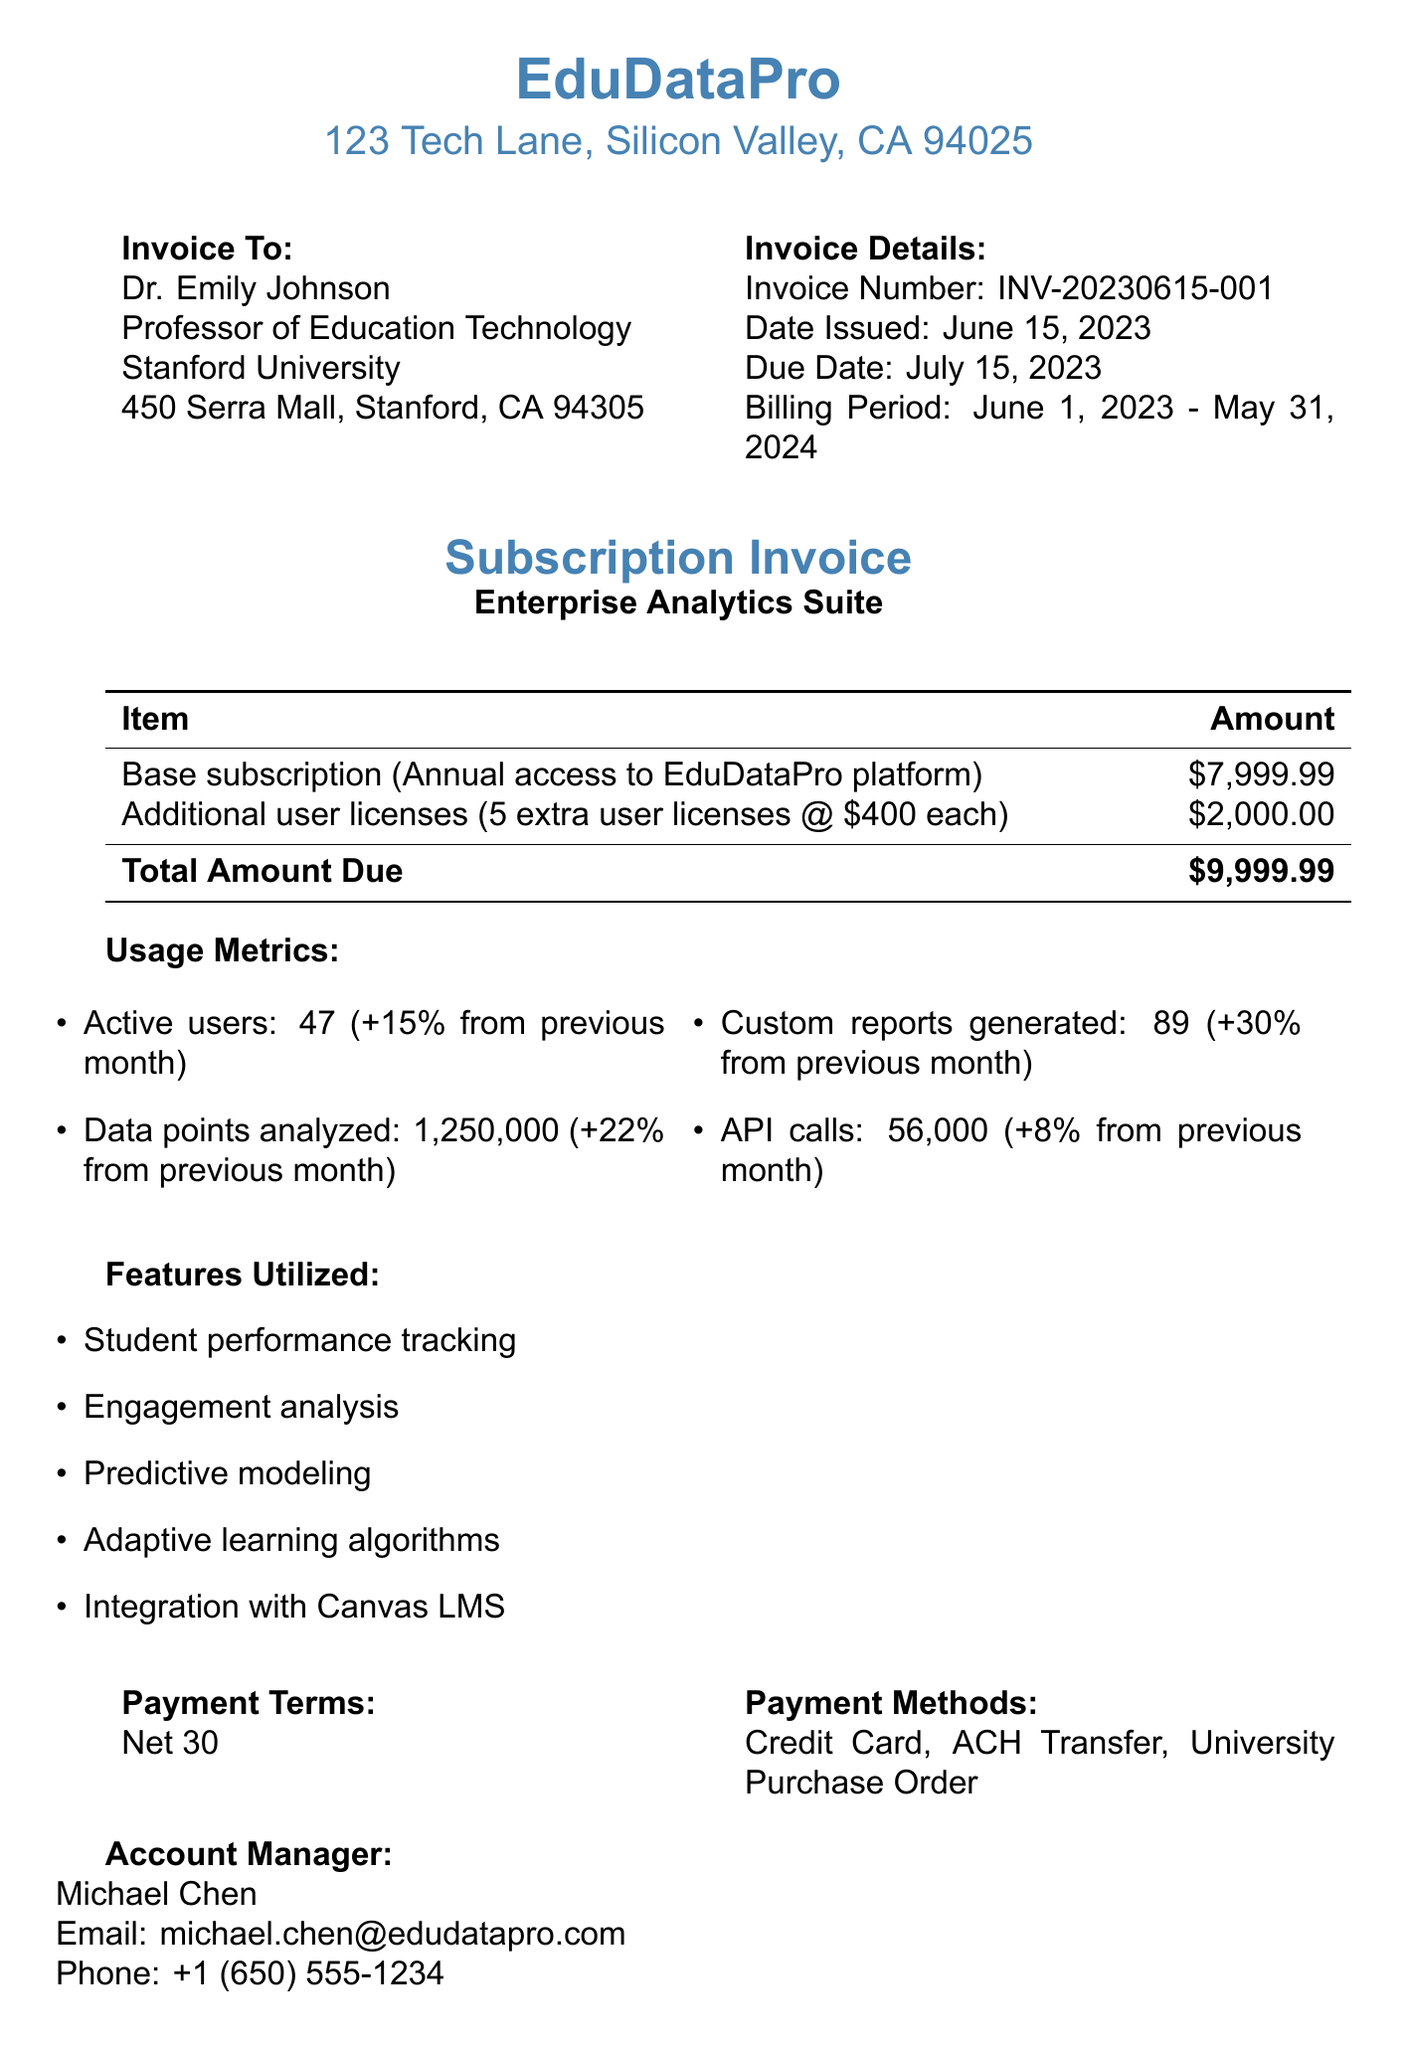What is the invoice number? The invoice number is stated prominently in the document, which is INV-20230615-001.
Answer: INV-20230615-001 Who issued the invoice? The invoice is issued by EduDataPro, as mentioned in the header of the document.
Answer: EduDataPro What is the billing period for the subscription? The billing period is specified, covering June 1, 2023 to May 31, 2024.
Answer: June 1, 2023 - May 31, 2024 How many additional user licenses were purchased? It is noted in the line items that 5 extra user licenses were purchased.
Answer: 5 What is the total amount due? The total amount due is explicitly indicated as $9999.99 at the end of the line items.
Answer: $9999.99 What change in active users is reported from the previous month? The document states that there was a 15% increase in active users compared to the previous month.
Answer: +15% Which feature utilized involves student performance? The document lists "Student performance tracking" as one of the features utilized in the subscription.
Answer: Student performance tracking What are the payment methods accepted? The acceptable payment methods are listed together, including Credit Card, ACH Transfer, and University Purchase Order.
Answer: Credit Card, ACH Transfer, University Purchase Order Who is the account manager? The name of the account manager is provided in the document, which is Michael Chen.
Answer: Michael Chen 